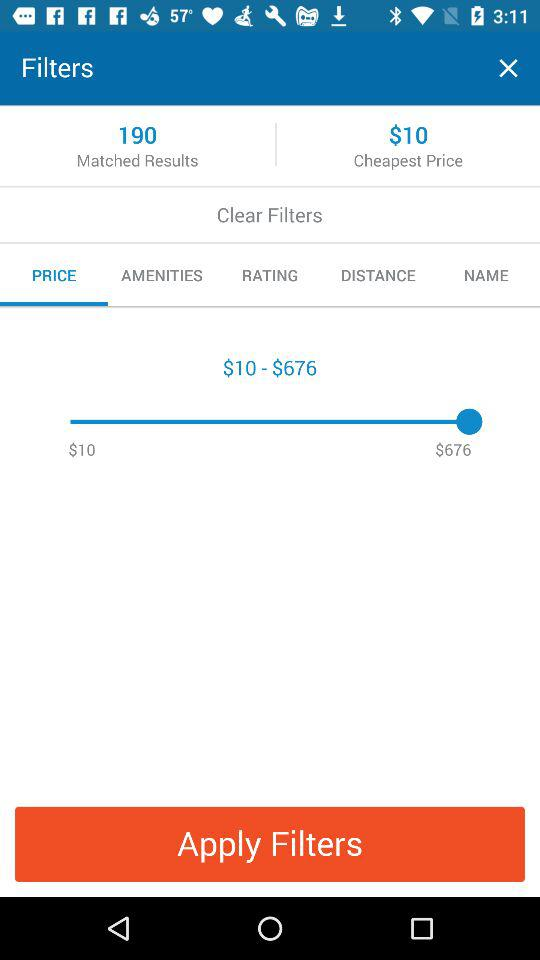What's the cheapest price? The cheapest price is $10. 